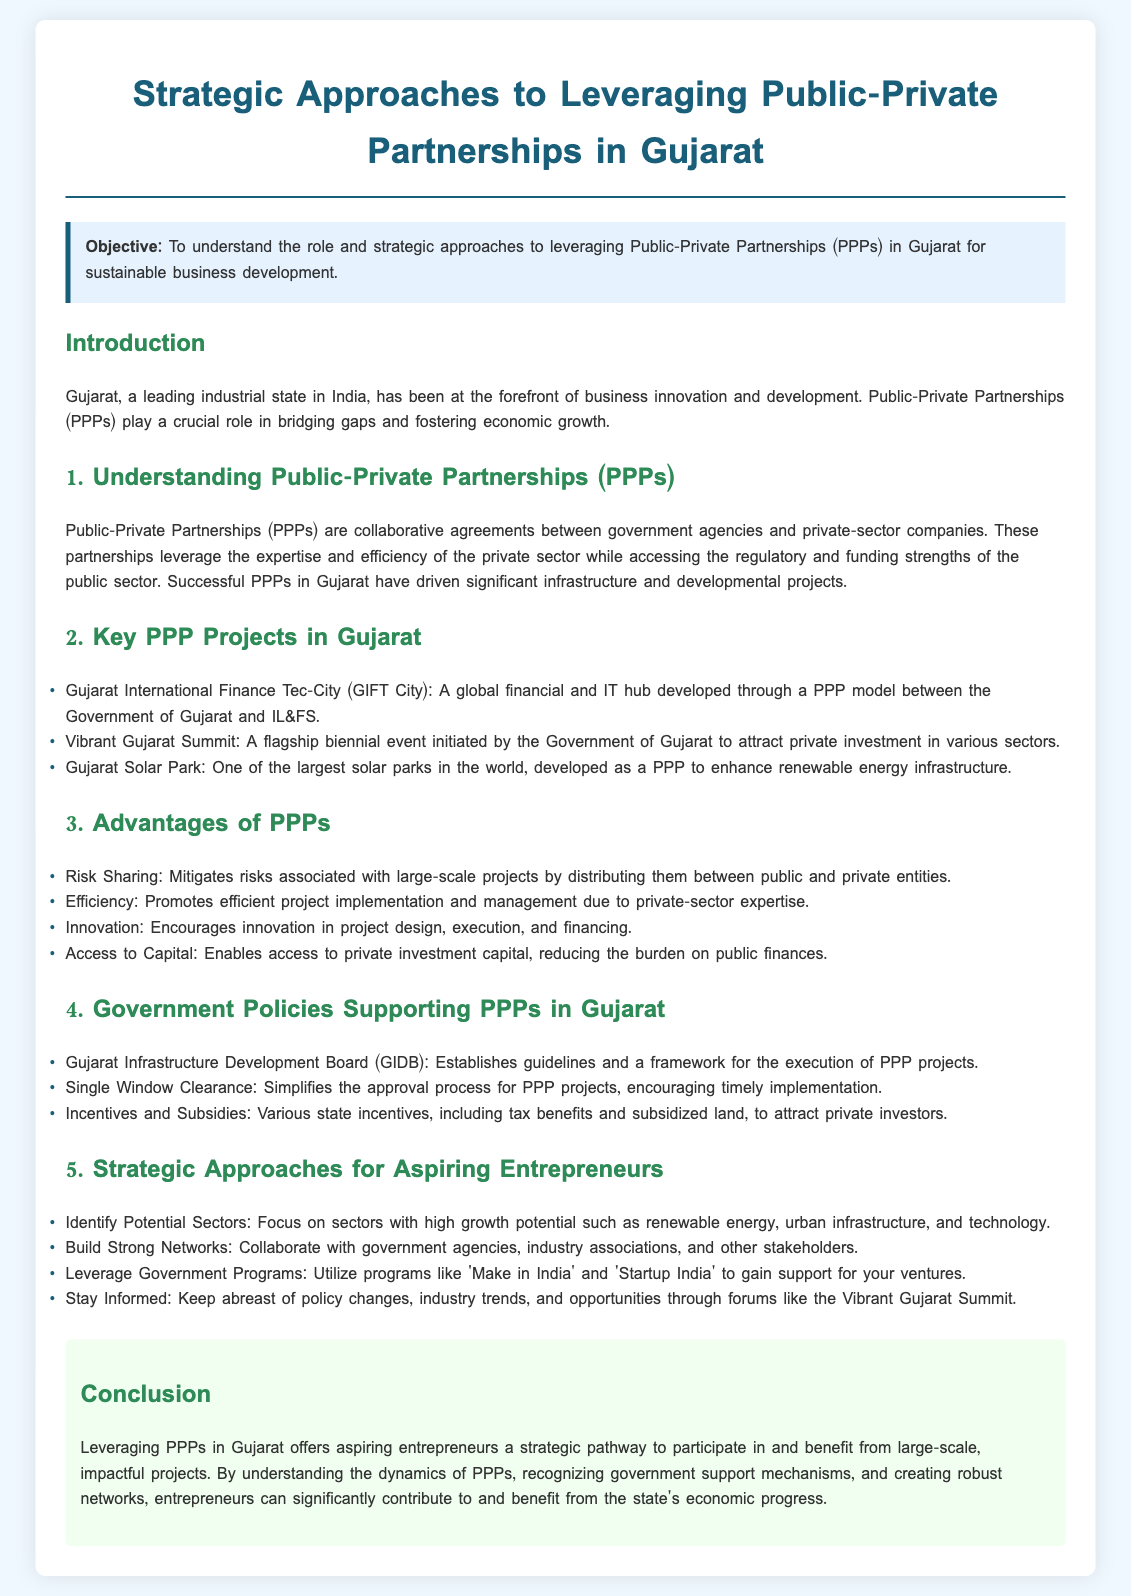What is the objective of the lesson plan? The objective is stated at the beginning of the document, focusing on understanding the role and strategic approaches to leveraging PPPs in Gujarat for sustainable business development.
Answer: To understand the role and strategic approaches to leveraging Public-Private Partnerships (PPPs) in Gujarat for sustainable business development What is a key PPP project in Gujarat? A specific example mentioned in the document of a key PPP project is GIFT City, which highlights collaboration between the Government and a private entity.
Answer: Gujarat International Finance Tec-City (GIFT City) What are two advantages of PPPs mentioned? The document outlines several advantages, two of which include risk sharing and efficiency in project management.
Answer: Risk Sharing, Efficiency What does GIDB stand for? The document refers to GIDB as an important government body that supports PPPs in Gujarat, signifying its role in the infrastructure development framework.
Answer: Gujarat Infrastructure Development Board Which sectors should aspiring entrepreneurs focus on? The lesson plan suggests focusing on sectors with high growth potential such as renewable energy, urban infrastructure, and technology.
Answer: Renewable energy, urban infrastructure, and technology What is the significance of the Vibrant Gujarat Summit? The document highlights the summit as a platform for attracting private investment and keeping abreast of policy changes and industry trends.
Answer: Attract private investment What is a strategic approach for aspiring entrepreneurs mentioned in the document? The document suggests collaborating with government agencies and industry associations as a strategic approach for aspiring entrepreneurs in Gujarat.
Answer: Build Strong Networks What color is used for the conclusion section? The document describes the color used for the conclusion section as light green, which is meant to visually separate it from the other sections.
Answer: Light green What does the lesson plan emphasize for entrepreneurs? The lesson plan emphasizes the importance of understanding the dynamics of PPPs and recognizing government support mechanisms for economic progress.
Answer: Understanding the dynamics of PPPs and recognizing government support mechanisms 